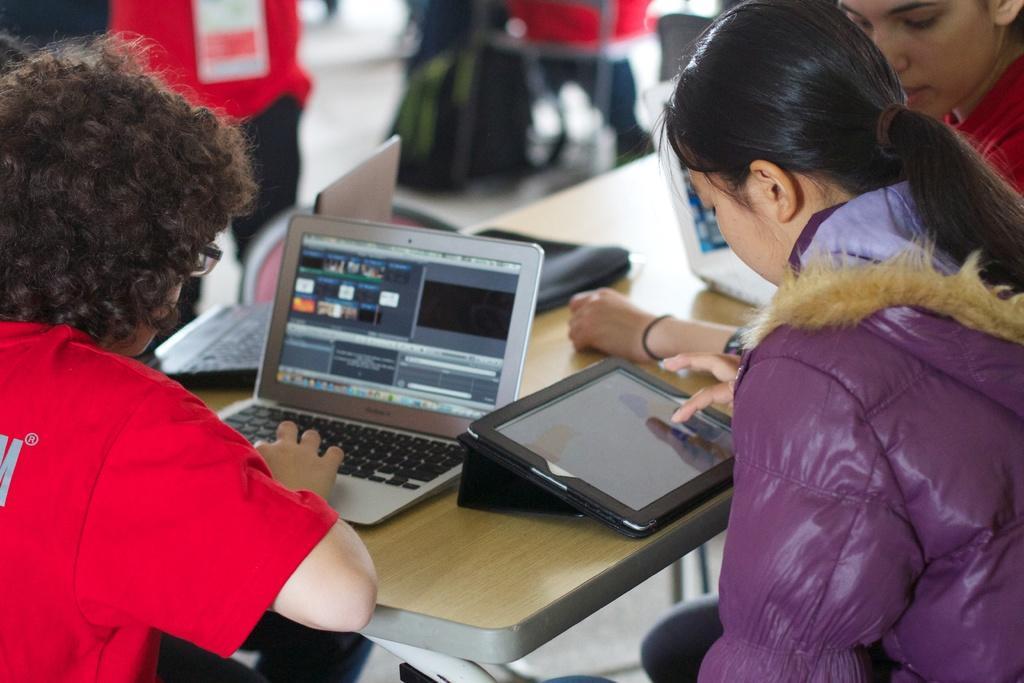Please provide a concise description of this image. In the picture we can see the table and near it, we can see some children are sitting on the chairs and working on a laptop and in the background also we can see some children sitting on the chairs and on the floor we can see a bag. 